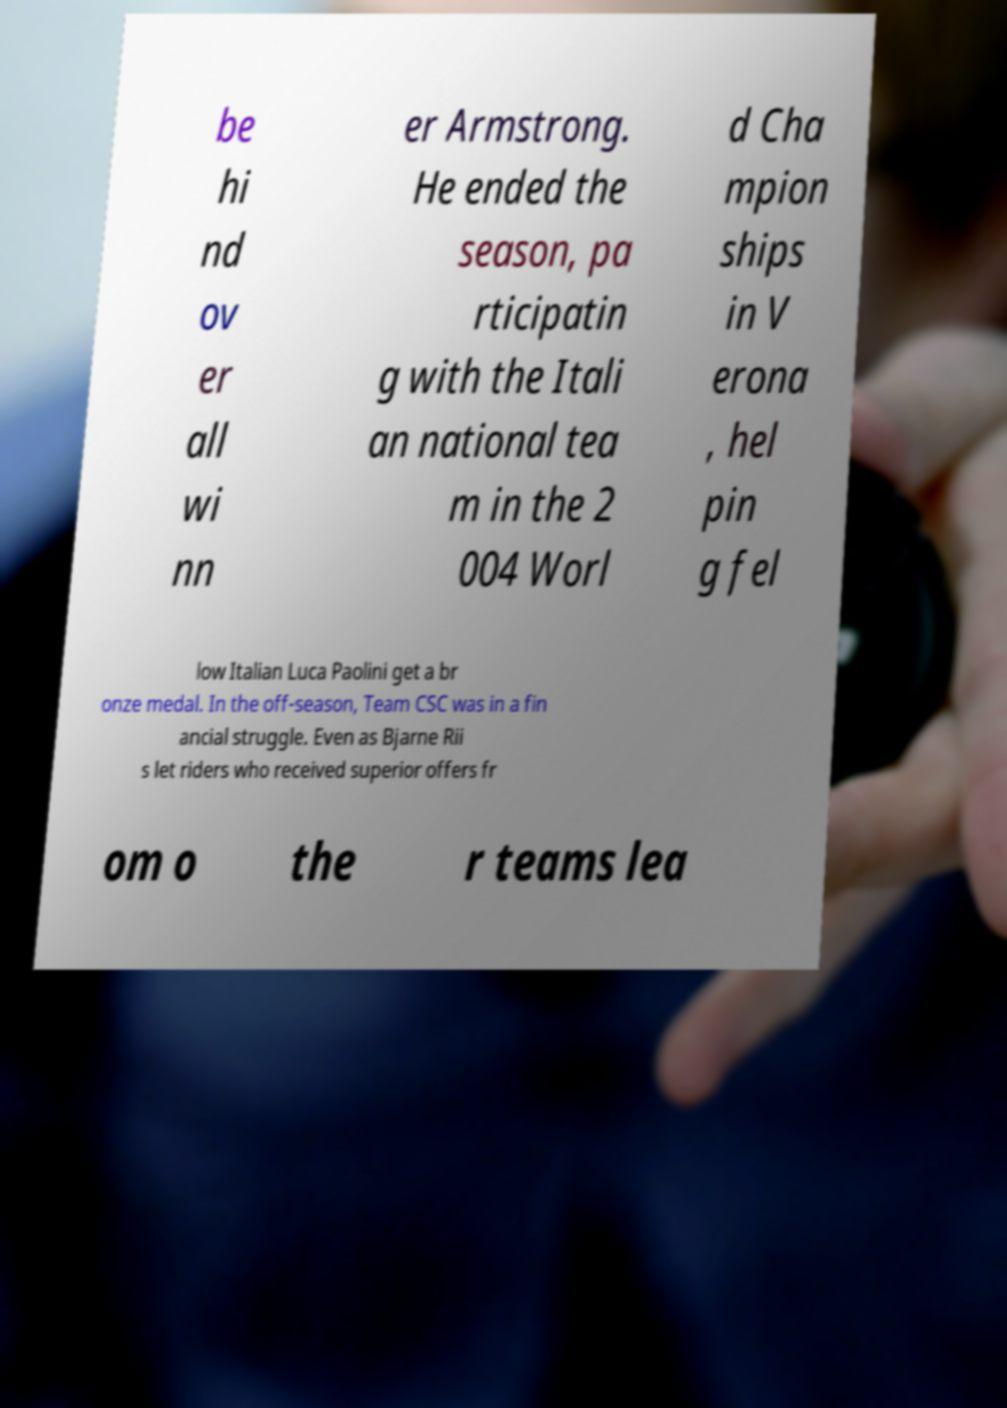I need the written content from this picture converted into text. Can you do that? be hi nd ov er all wi nn er Armstrong. He ended the season, pa rticipatin g with the Itali an national tea m in the 2 004 Worl d Cha mpion ships in V erona , hel pin g fel low Italian Luca Paolini get a br onze medal. In the off-season, Team CSC was in a fin ancial struggle. Even as Bjarne Rii s let riders who received superior offers fr om o the r teams lea 